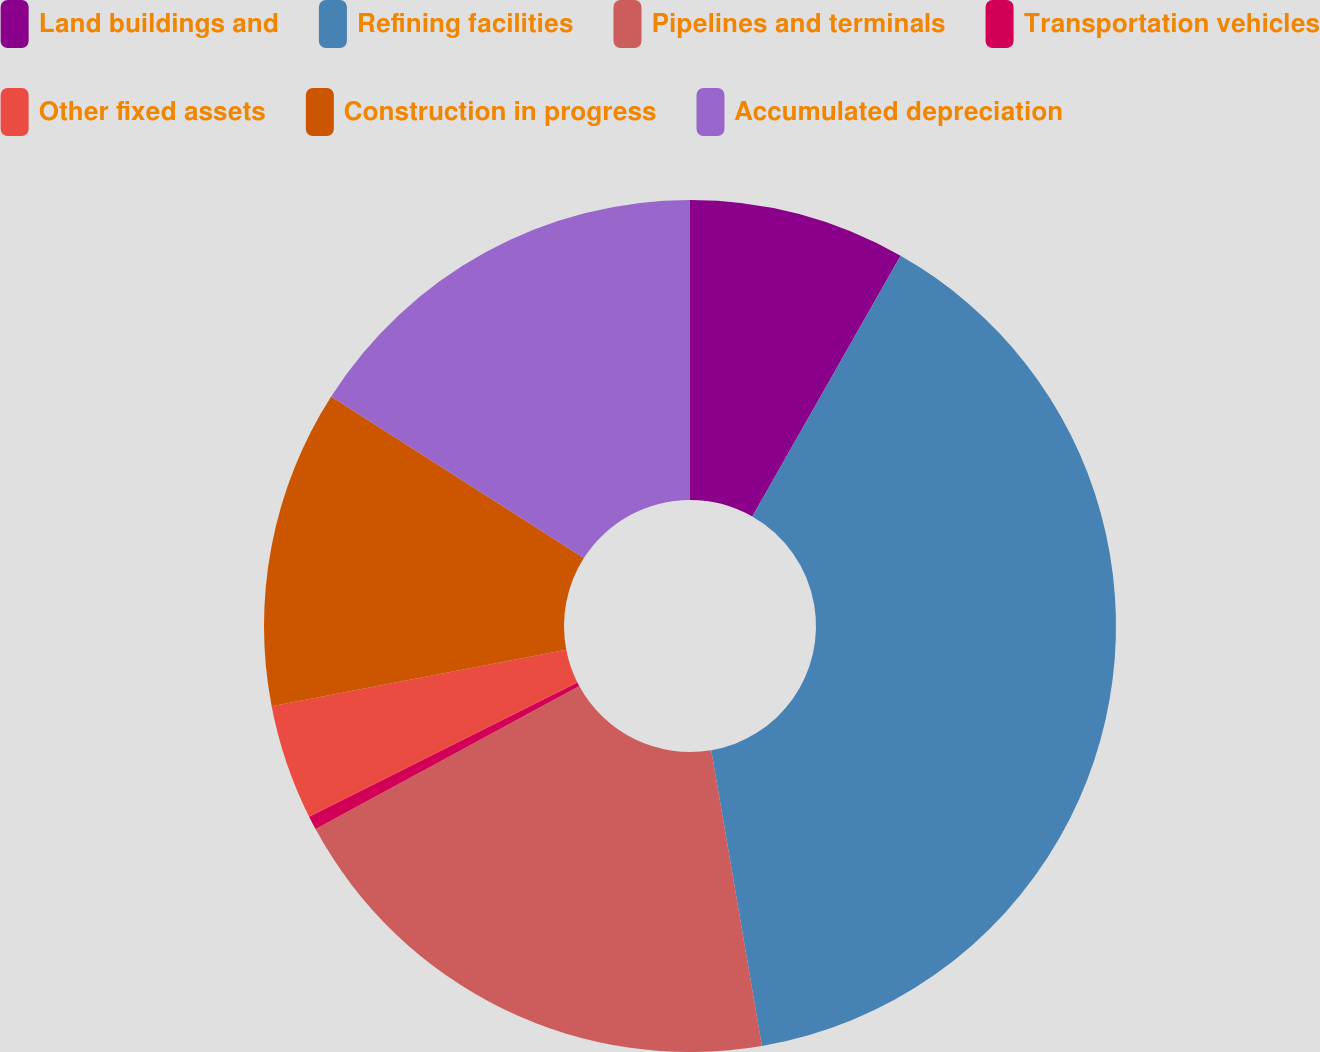Convert chart. <chart><loc_0><loc_0><loc_500><loc_500><pie_chart><fcel>Land buildings and<fcel>Refining facilities<fcel>Pipelines and terminals<fcel>Transportation vehicles<fcel>Other fixed assets<fcel>Construction in progress<fcel>Accumulated depreciation<nl><fcel>8.23%<fcel>39.07%<fcel>19.79%<fcel>0.52%<fcel>4.37%<fcel>12.08%<fcel>15.94%<nl></chart> 